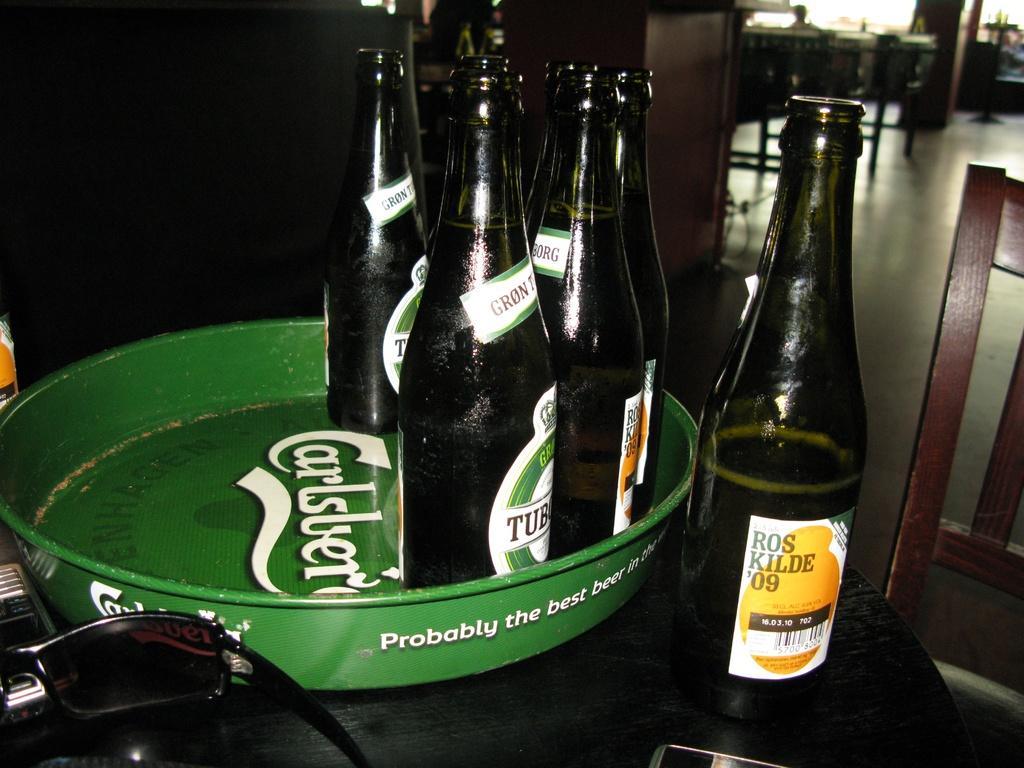How would you summarize this image in a sentence or two? In this image, There is a table which is in black color on that table there is a tray of green color,In that there are some beers bottles which are in black color, In the right side of the image there is a chair which is in brown and in the background of the image there is a black color wall. 